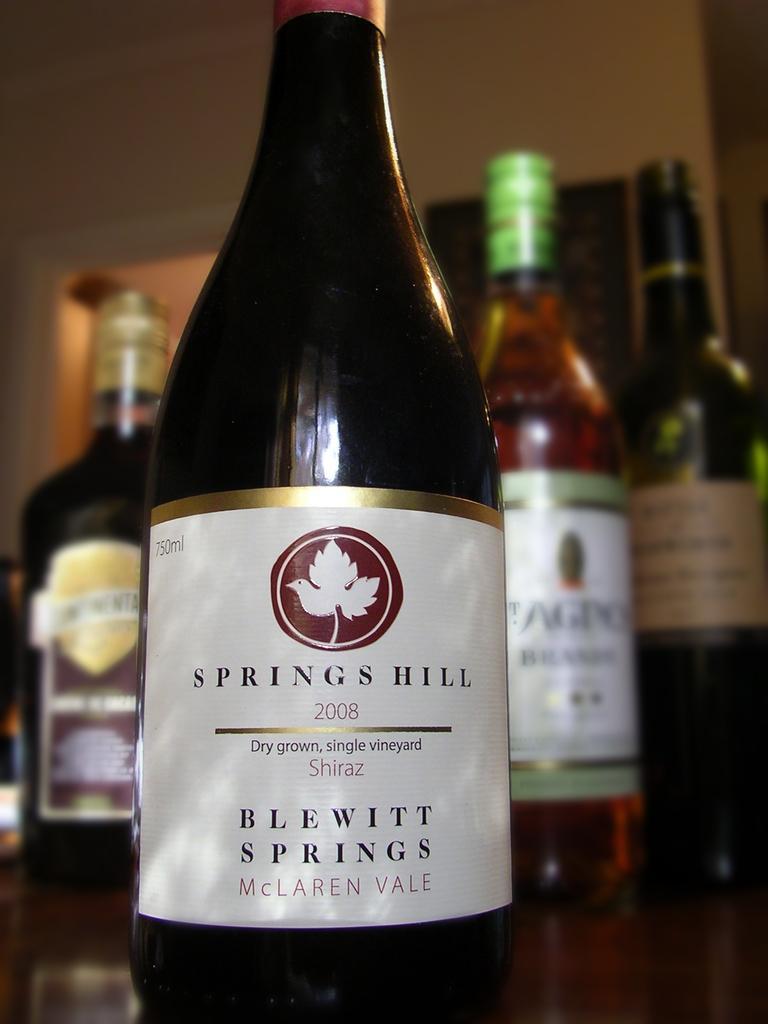Could you give a brief overview of what you see in this image? In this picture there is a wine bottle placed on the table. In the background there are some bottles and a wall here. 